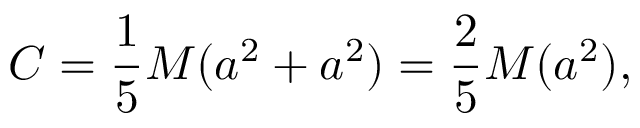<formula> <loc_0><loc_0><loc_500><loc_500>C = { \frac { 1 } { 5 } } M ( a ^ { 2 } + a ^ { 2 } ) = { \frac { 2 } { 5 } } M ( a ^ { 2 } ) ,</formula> 